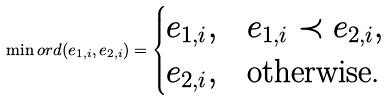<formula> <loc_0><loc_0><loc_500><loc_500>\min o r d ( e _ { 1 , i } , e _ { 2 , i } ) = \begin{cases} e _ { 1 , i } , & e _ { 1 , i } \prec e _ { 2 , i } , \\ e _ { 2 , i } , & \text {otherwise.} \end{cases}</formula> 